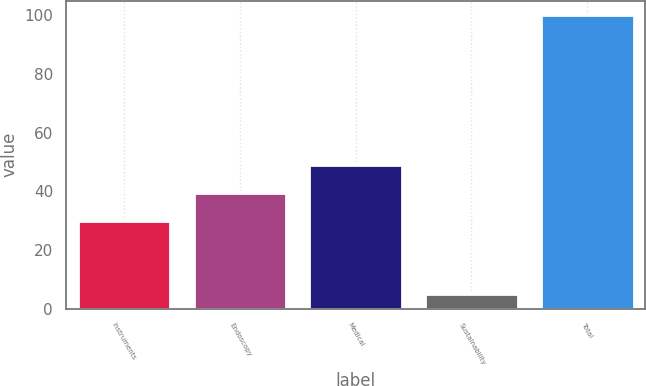Convert chart to OTSL. <chart><loc_0><loc_0><loc_500><loc_500><bar_chart><fcel>Instruments<fcel>Endoscopy<fcel>Medical<fcel>Sustainability<fcel>Total<nl><fcel>30<fcel>39.5<fcel>49<fcel>5<fcel>100<nl></chart> 